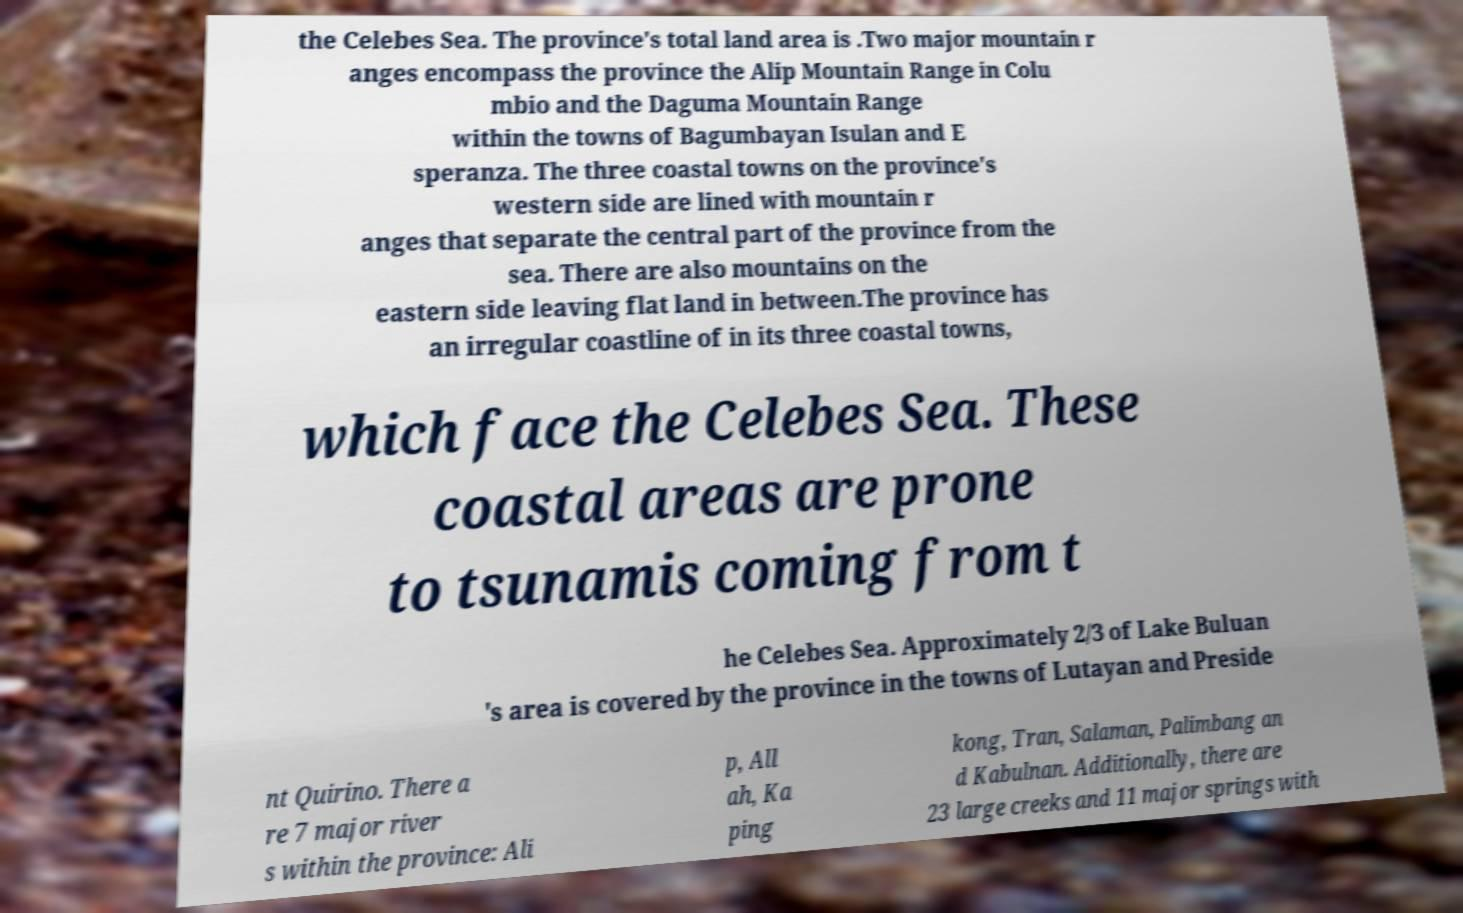Please identify and transcribe the text found in this image. the Celebes Sea. The province's total land area is .Two major mountain r anges encompass the province the Alip Mountain Range in Colu mbio and the Daguma Mountain Range within the towns of Bagumbayan Isulan and E speranza. The three coastal towns on the province's western side are lined with mountain r anges that separate the central part of the province from the sea. There are also mountains on the eastern side leaving flat land in between.The province has an irregular coastline of in its three coastal towns, which face the Celebes Sea. These coastal areas are prone to tsunamis coming from t he Celebes Sea. Approximately 2/3 of Lake Buluan 's area is covered by the province in the towns of Lutayan and Preside nt Quirino. There a re 7 major river s within the province: Ali p, All ah, Ka ping kong, Tran, Salaman, Palimbang an d Kabulnan. Additionally, there are 23 large creeks and 11 major springs with 